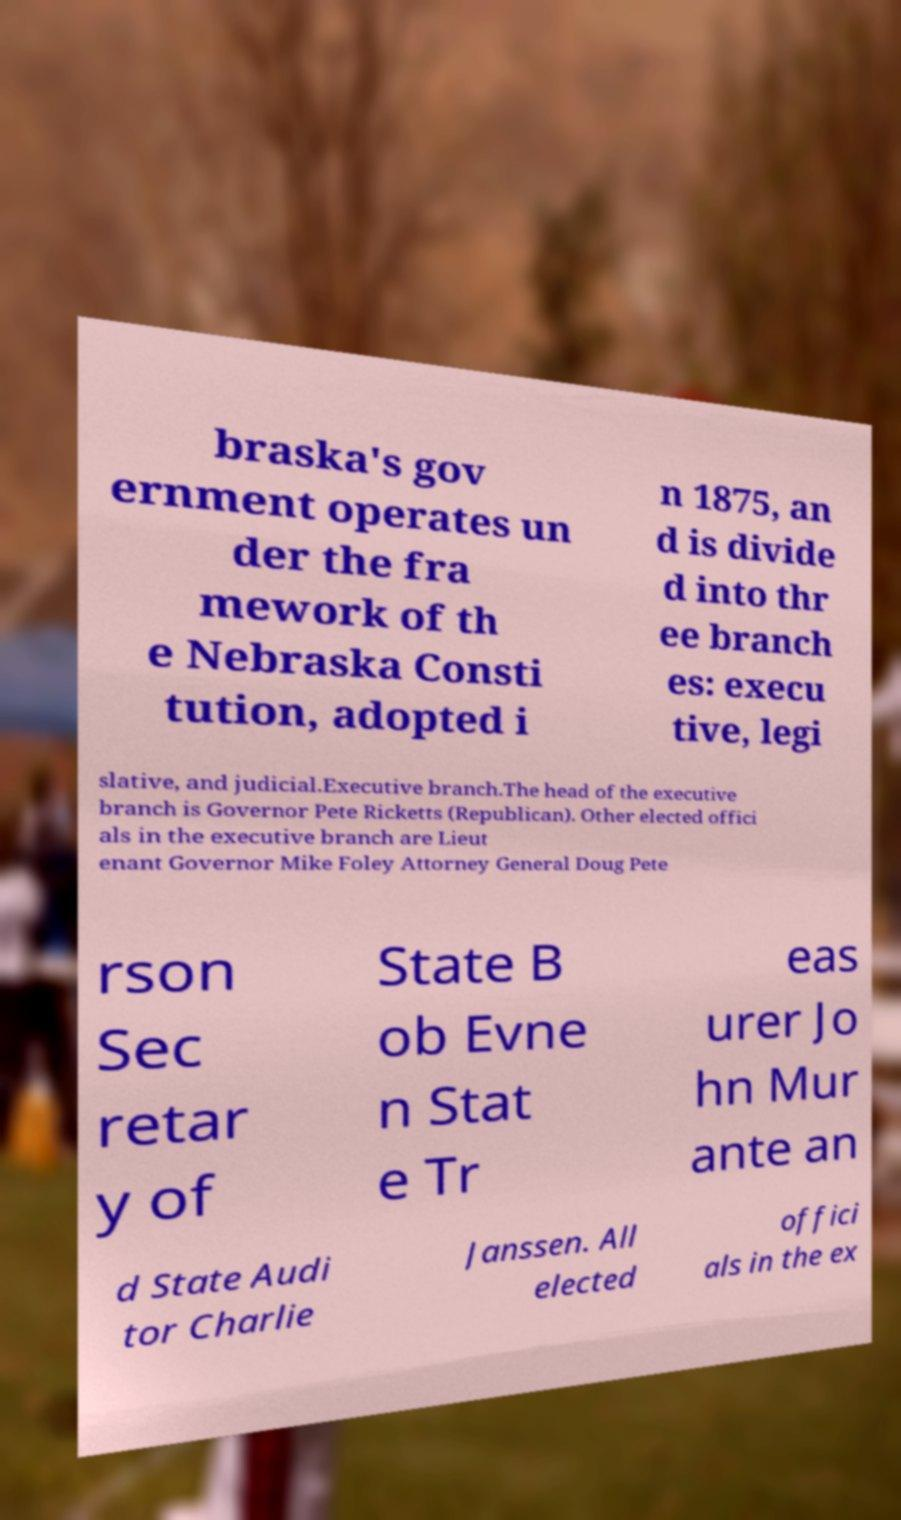Could you assist in decoding the text presented in this image and type it out clearly? braska's gov ernment operates un der the fra mework of th e Nebraska Consti tution, adopted i n 1875, an d is divide d into thr ee branch es: execu tive, legi slative, and judicial.Executive branch.The head of the executive branch is Governor Pete Ricketts (Republican). Other elected offici als in the executive branch are Lieut enant Governor Mike Foley Attorney General Doug Pete rson Sec retar y of State B ob Evne n Stat e Tr eas urer Jo hn Mur ante an d State Audi tor Charlie Janssen. All elected offici als in the ex 